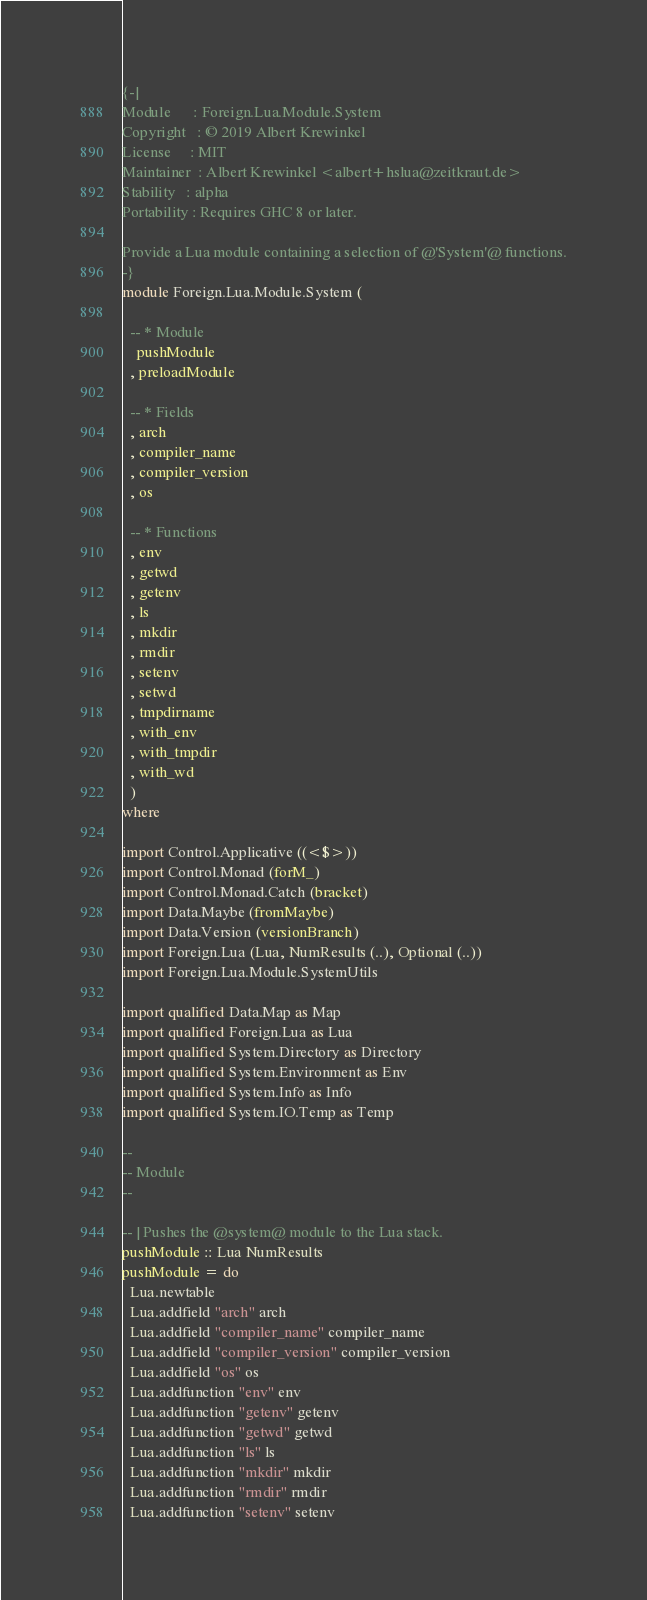<code> <loc_0><loc_0><loc_500><loc_500><_Haskell_>{-|
Module      : Foreign.Lua.Module.System
Copyright   : © 2019 Albert Krewinkel
License     : MIT
Maintainer  : Albert Krewinkel <albert+hslua@zeitkraut.de>
Stability   : alpha
Portability : Requires GHC 8 or later.

Provide a Lua module containing a selection of @'System'@ functions.
-}
module Foreign.Lua.Module.System (

  -- * Module
    pushModule
  , preloadModule

  -- * Fields
  , arch
  , compiler_name
  , compiler_version
  , os

  -- * Functions
  , env
  , getwd
  , getenv
  , ls
  , mkdir
  , rmdir
  , setenv
  , setwd
  , tmpdirname
  , with_env
  , with_tmpdir
  , with_wd
  )
where

import Control.Applicative ((<$>))
import Control.Monad (forM_)
import Control.Monad.Catch (bracket)
import Data.Maybe (fromMaybe)
import Data.Version (versionBranch)
import Foreign.Lua (Lua, NumResults (..), Optional (..))
import Foreign.Lua.Module.SystemUtils

import qualified Data.Map as Map
import qualified Foreign.Lua as Lua
import qualified System.Directory as Directory
import qualified System.Environment as Env
import qualified System.Info as Info
import qualified System.IO.Temp as Temp

--
-- Module
--

-- | Pushes the @system@ module to the Lua stack.
pushModule :: Lua NumResults
pushModule = do
  Lua.newtable
  Lua.addfield "arch" arch
  Lua.addfield "compiler_name" compiler_name
  Lua.addfield "compiler_version" compiler_version
  Lua.addfield "os" os
  Lua.addfunction "env" env
  Lua.addfunction "getenv" getenv
  Lua.addfunction "getwd" getwd
  Lua.addfunction "ls" ls
  Lua.addfunction "mkdir" mkdir
  Lua.addfunction "rmdir" rmdir
  Lua.addfunction "setenv" setenv</code> 